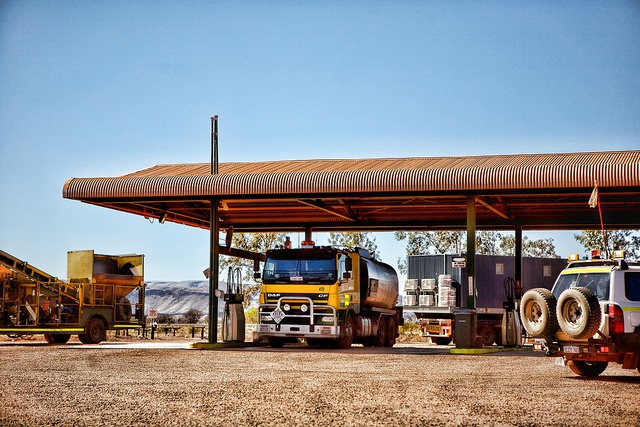Describe the objects in this image and their specific colors. I can see truck in gray, black, maroon, darkgray, and brown tones, car in gray, black, maroon, ivory, and darkgray tones, truck in gray, black, maroon, and darkgray tones, and truck in gray, black, maroon, and lightgray tones in this image. 